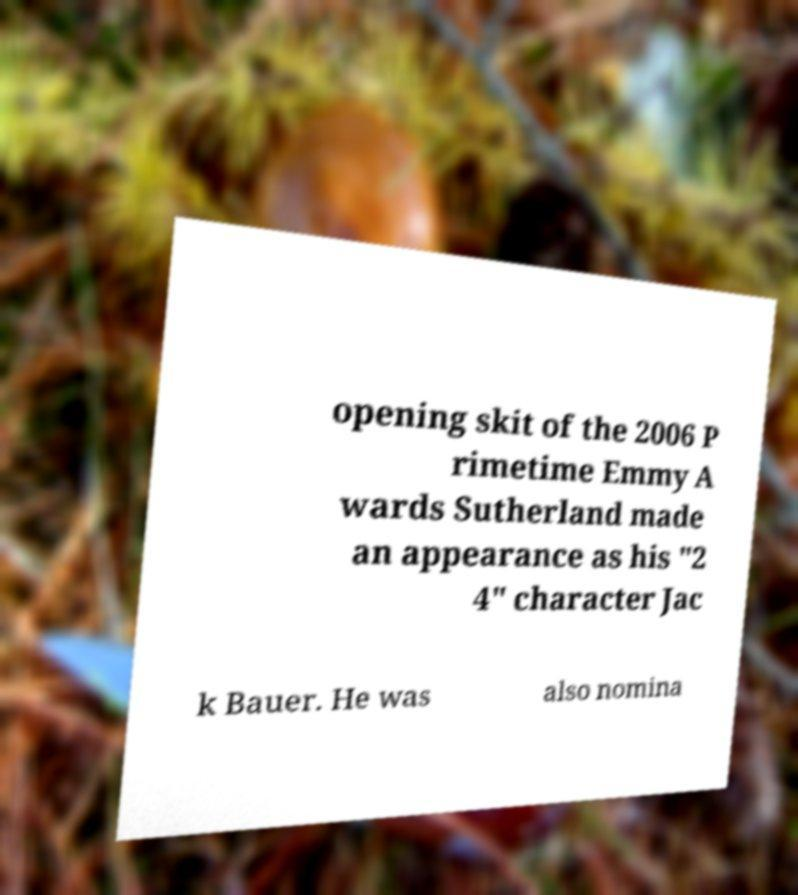There's text embedded in this image that I need extracted. Can you transcribe it verbatim? opening skit of the 2006 P rimetime Emmy A wards Sutherland made an appearance as his "2 4" character Jac k Bauer. He was also nomina 